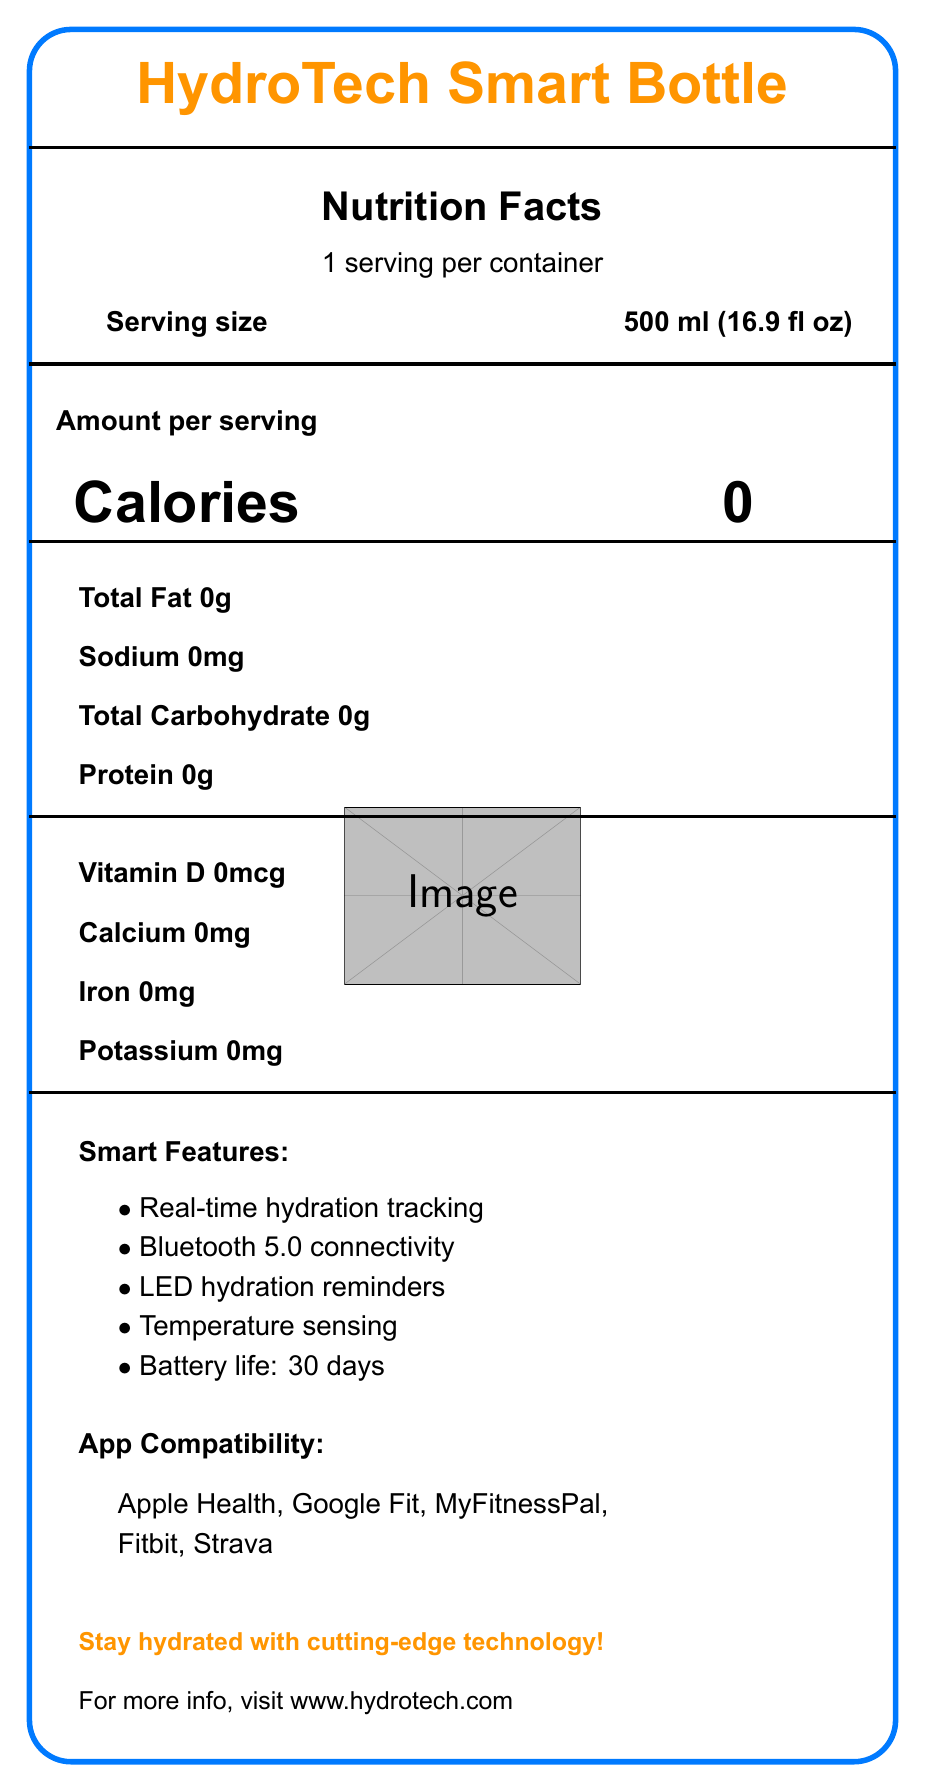what is the serving size of the HydroTech Smart Bottle? The serving size is clearly listed as "500 ml (16.9 fl oz)" on the label.
Answer: 500 ml (16.9 fl oz) how many calories are in one serving? The document explicitly states that there are 0 calories per serving.
Answer: 0 what are the main materials used in the HydroTech Smart Bottle? The document lists these materials under the "materials" section.
Answer: BPA-free Tritan plastic, Food-grade stainless steel, Silicone grip how long is the battery life of the HydroTech Smart Bottle? Battery life is mentioned as one of the smart features, stating it lasts 30 days.
Answer: 30 days which fitness apps are compatible with the HydroTech Smart Bottle? The document lists these apps under the "app compatibility" section.
Answer: Apple Health, Google Fit, MyFitnessPal, Fitbit, Strava what are some of the smart features of the HydroTech Smart Bottle? The document lists these under the "smart features" section.
Answer: Real-time hydration tracking, Bluetooth 5.0 connectivity, LED hydration reminders, Temperature sensing, Battery life: 30 days how many servings are in one container of the HydroTech Smart Bottle? The document states "1 serving per container."
Answer: 1 which of the following is NOT a smart feature of the HydroTech Smart Bottle? A. Real-time hydration tracking B. Automatic refills C. Bluetooth 5.0 connectivity D. LED hydration reminders The document lists real-time hydration tracking, Bluetooth connectivity, and LED reminders, but not automatic refills.
Answer: B what kind of water quality sensors are included in the HydroTech Smart Bottle? These are listed under the "water quality sensors" section of the document.
Answer: pH level, Total dissolved solids (TDS), Temperature does the HydroTech Smart Bottle track daily water consumption? Tracking daily water consumption is listed under "data metrics."
Answer: Yes how eco-friendly is the HydroTech Smart Bottle? The document lists these features under the "eco-friendly features" section.
Answer: Reusable design, Recyclable packaging, Energy-efficient sensors what is the dimension of the HydroTech Smart Bottle? The document provides these measurements under the "dimensions" section.
Answer: 9.5 x 3.1 inches (24.1 x 7.9 cm) which hydration goals can the HydroTech Smart Bottle help with? The goals are listed under the "hydration goals" section.
Answer: Daily water intake, Workout hydration, Personalized recommendations how should the HydroTech Smart Bottle be charged? The document states that the bottle uses USB-C fast charging.
Answer: USB-C fast charging what is the primary purpose of the HydroTech Smart Bottle? The document focuses on hydration tracking, app compatibility, and smart features aimed at maintaining hydration.
Answer: To keep the user hydrated with the help of technology what warranty is offered with the HydroTech Smart Bottle? The document mentions a 2-year limited warranty.
Answer: 2-year limited warranty is the HydroTech Smart Bottle compatible with MyFitnessPal? MyFitnessPal is listed under "app compatibility."
Answer: Yes how much does the HydroTech Smart Bottle weigh? The weight is listed in the document.
Answer: 350g (12.3 oz) does the HydroTech Smart Bottle support voice commands with Alexa? The document mentions voice command support for Alexa and Google Assistant.
Answer: Yes describe the visual layout and main features of the HydroTech Smart Bottle document. The document uses a structured layout with headings, lists, and a visual representation of the bottle to provide comprehensive information about the HydroTech Smart Bottle.
Answer: The document features the HydroTech Smart Bottle branding prominently at the top, followed by nutritional information, smart features, app compatibility, hydration goals, and eco-friendly features. It includes a detailed breakdown of materials, dimensions, and water quality sensors. does the HydroTech Smart Bottle use high-resolution sensors? The document does not specify the resolution of the sensors.
Answer: Not enough information 